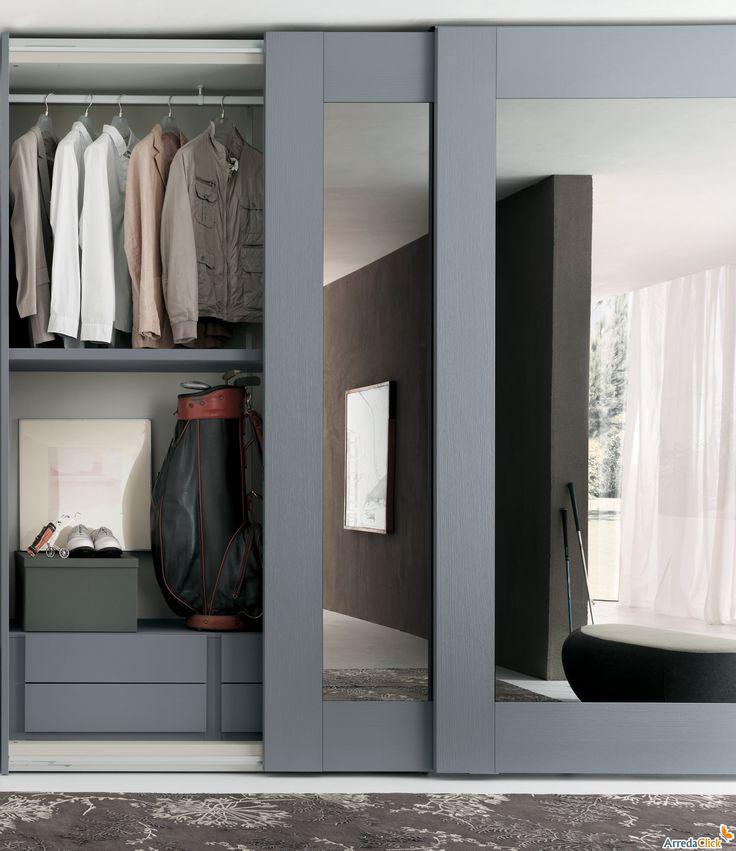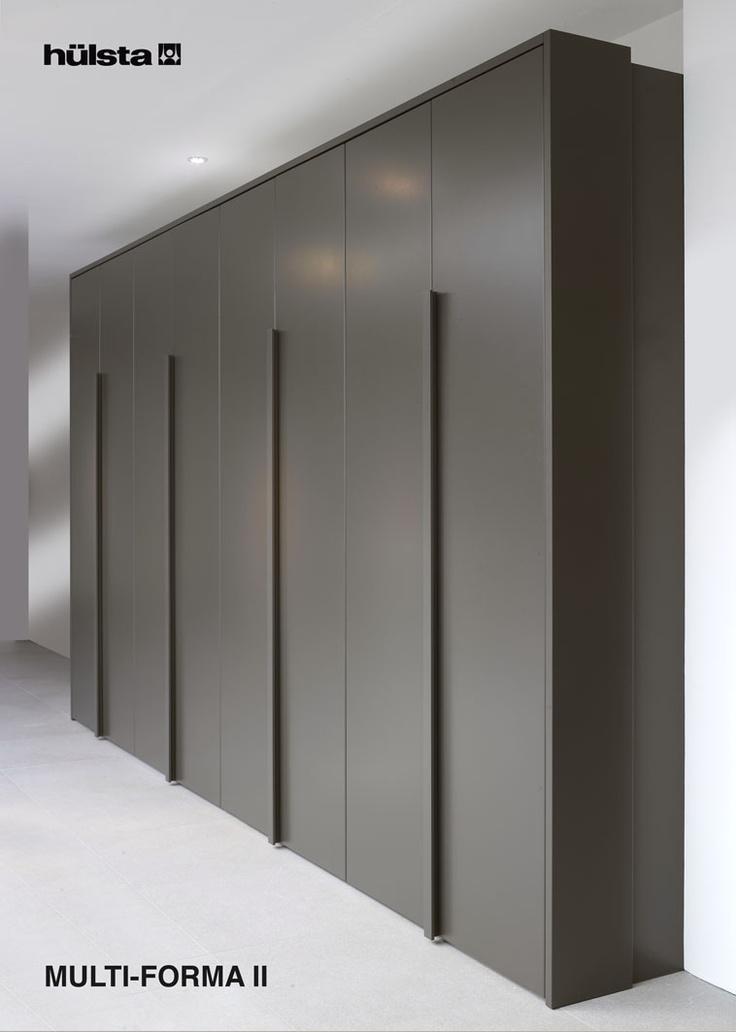The first image is the image on the left, the second image is the image on the right. Evaluate the accuracy of this statement regarding the images: "An image shows a wardrobe with partly open doors revealing items and shelves inside.". Is it true? Answer yes or no. Yes. 